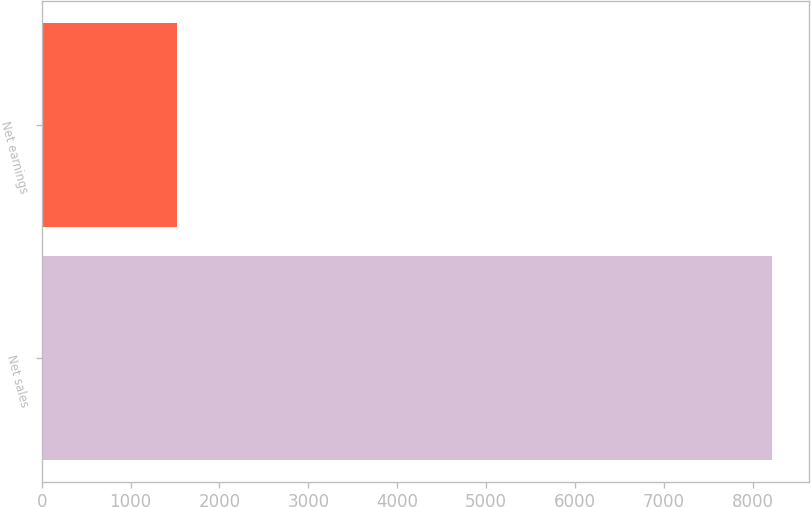Convert chart to OTSL. <chart><loc_0><loc_0><loc_500><loc_500><bar_chart><fcel>Net sales<fcel>Net earnings<nl><fcel>8218<fcel>1519<nl></chart> 